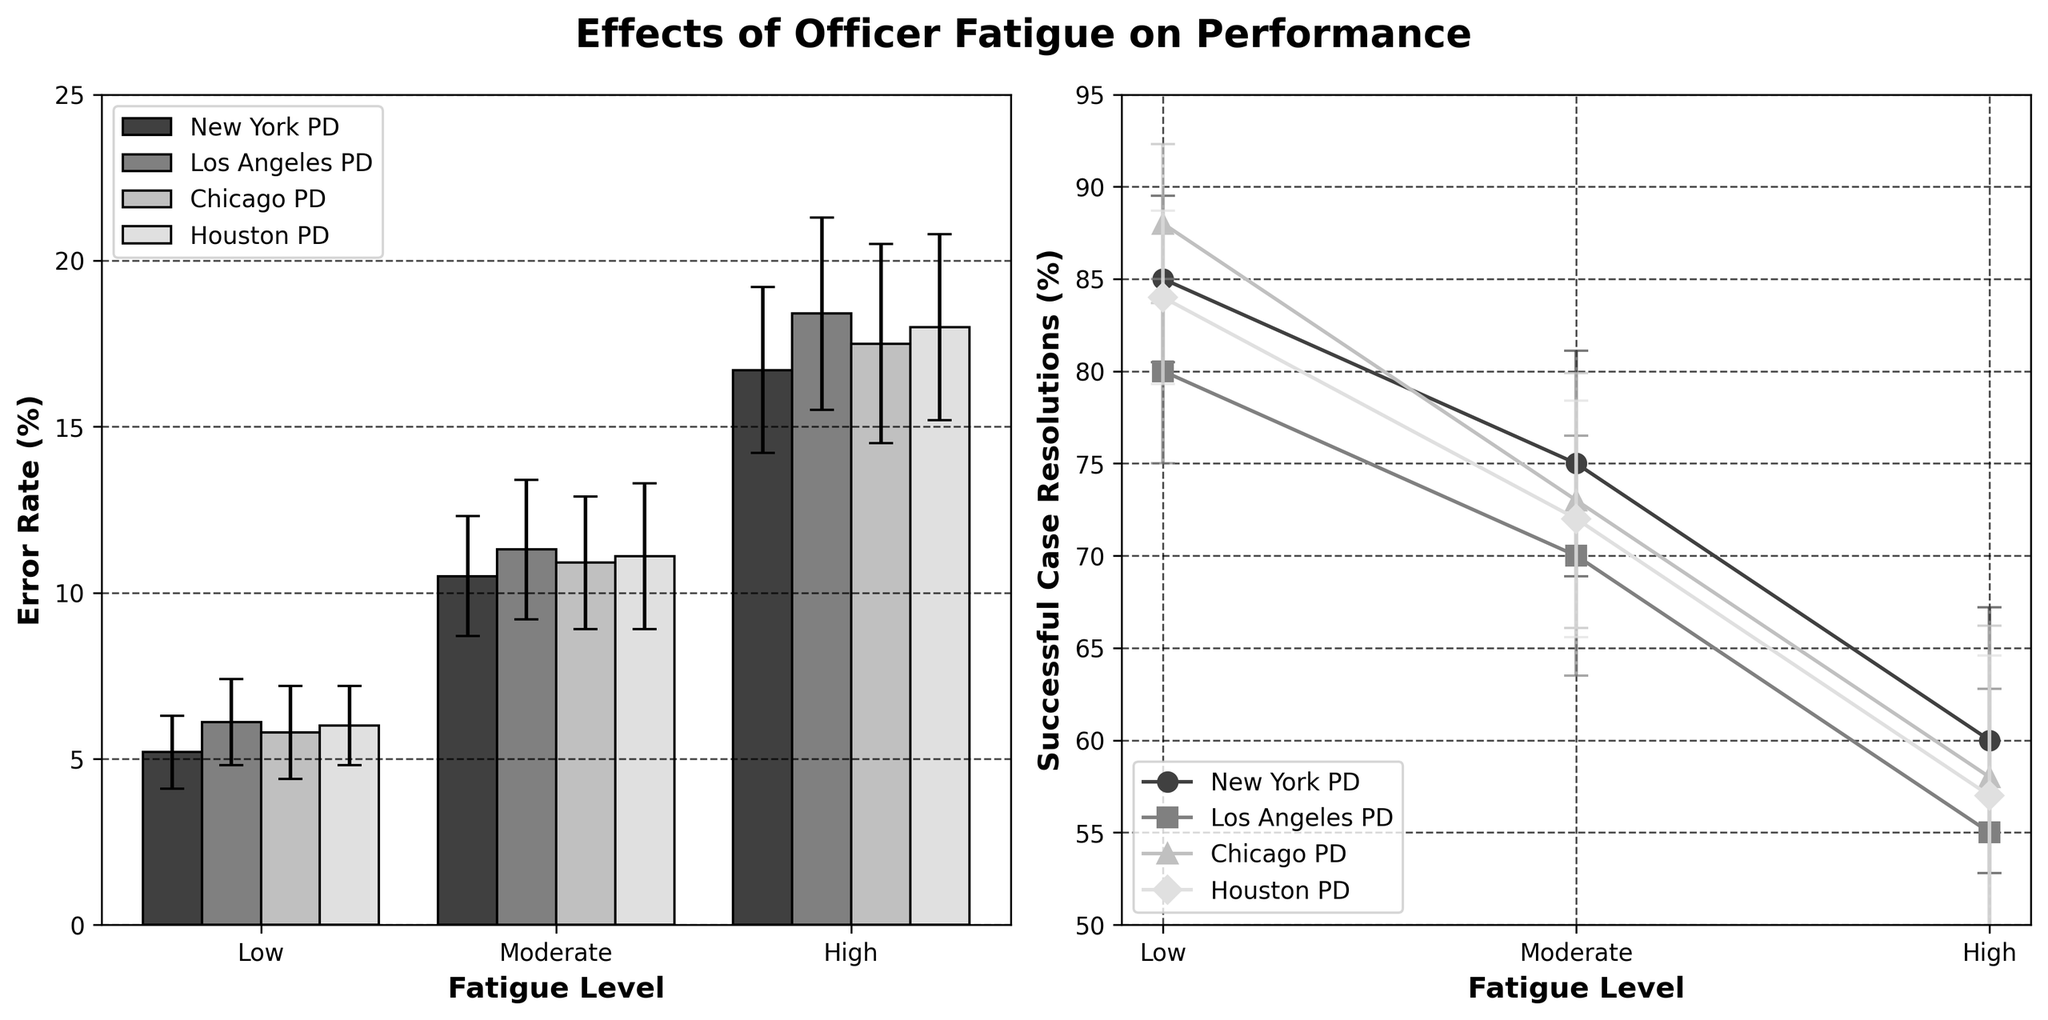how many fatigue levels are shown in the plot? The figure displays three fatigue levels on the x-axis: Low, Moderate, and High.
Answer: 3 What is the title of the figure? The title is located above the plots and reads, "Effects of Officer Fatigue on Performance".
Answer: Effects of Officer Fatigue on Performance Which department has the highest error rate at the 'High' fatigue level? By looking at the left subplot, for the 'High' fatigue level, the bar representing 'Los Angeles PD' is the tallest.
Answer: Los Angeles PD What is the error rate for Chicago PD at the 'Moderate' fatigue level? Check the first subplot for the 'Moderate' fatigue level and identify the height of the bar labeled 'Chicago PD'.
Answer: 10.9 Which department shows the greatest decline in successful case resolutions from 'Low' to 'High' fatigue levels? Observing the second subplot, the steepest line from 'Low' to 'High' fatigue levels represents 'Los Angeles PD'.
Answer: Los Angeles PD What's the largest standard deviation for successful case resolutions among all departments? Check the error bars in the second subplot and find the largest. 'Los Angeles PD' at 'High' fatigue level has the largest bar.
Answer: 7.8 Which department has the lowest error rate at the 'Low' fatigue level? From the left subplot, the shortest bar at the 'Low' fatigue level represents 'New York PD'.
Answer: New York PD What is the difference in successful case resolutions between 'Low' and 'High' fatigue levels for Houston PD? In the second subplot, identify the successful case resolutions at 'Low' and 'High' fatigue levels for 'Houston PD': 84% - 57% = 27%.
Answer: 27 Which department has the smallest increase in error rate from 'Moderate' to 'High' fatigue levels? On the left subplot, the smallest difference in height between the 'Moderate' and 'High' bars is 'Chicago PD'.
Answer: Chicago PD What is the trend of error rates across different fatigue levels for New York PD? From the first subplot, the bars for 'New York PD' increase as fatigue levels go from 'Low' to 'High'.
Answer: Increasing 